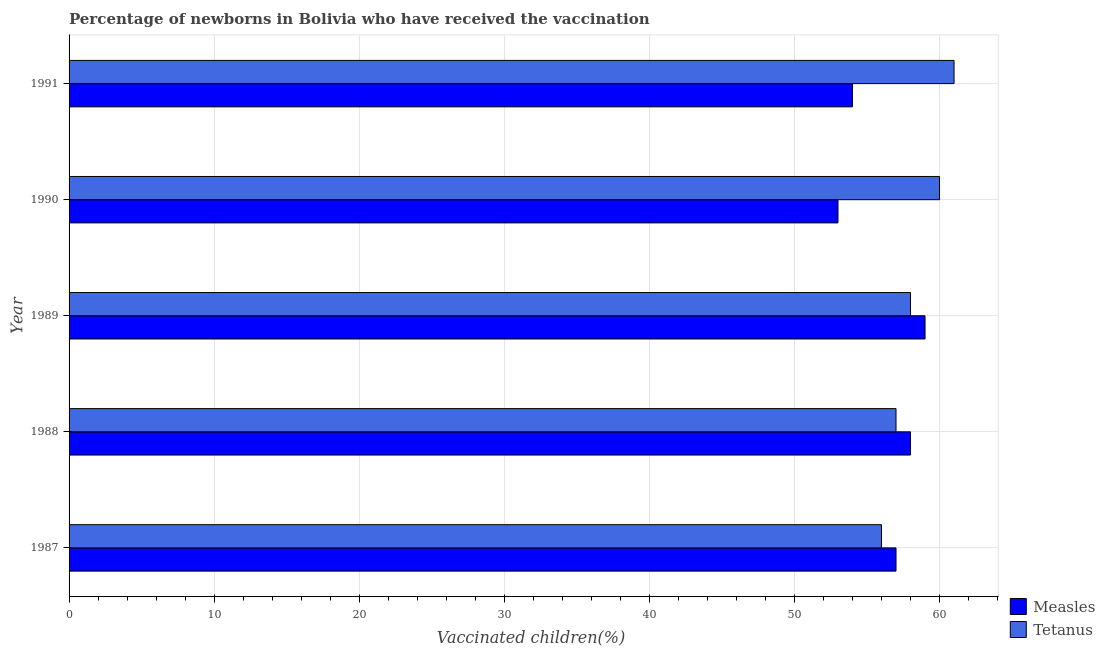How many groups of bars are there?
Ensure brevity in your answer.  5. Are the number of bars on each tick of the Y-axis equal?
Your answer should be compact. Yes. How many bars are there on the 3rd tick from the top?
Your answer should be very brief. 2. How many bars are there on the 1st tick from the bottom?
Your response must be concise. 2. What is the percentage of newborns who received vaccination for tetanus in 1991?
Offer a very short reply. 61. Across all years, what is the maximum percentage of newborns who received vaccination for measles?
Give a very brief answer. 59. Across all years, what is the minimum percentage of newborns who received vaccination for tetanus?
Your answer should be very brief. 56. In which year was the percentage of newborns who received vaccination for measles maximum?
Keep it short and to the point. 1989. In which year was the percentage of newborns who received vaccination for tetanus minimum?
Make the answer very short. 1987. What is the total percentage of newborns who received vaccination for tetanus in the graph?
Provide a short and direct response. 292. What is the difference between the percentage of newborns who received vaccination for tetanus in 1988 and that in 1991?
Make the answer very short. -4. What is the difference between the percentage of newborns who received vaccination for measles in 1991 and the percentage of newborns who received vaccination for tetanus in 1987?
Offer a very short reply. -2. What is the average percentage of newborns who received vaccination for tetanus per year?
Keep it short and to the point. 58.4. In the year 1988, what is the difference between the percentage of newborns who received vaccination for measles and percentage of newborns who received vaccination for tetanus?
Give a very brief answer. 1. What is the ratio of the percentage of newborns who received vaccination for measles in 1988 to that in 1991?
Your answer should be compact. 1.07. Is the percentage of newborns who received vaccination for measles in 1990 less than that in 1991?
Make the answer very short. Yes. Is the difference between the percentage of newborns who received vaccination for measles in 1989 and 1990 greater than the difference between the percentage of newborns who received vaccination for tetanus in 1989 and 1990?
Your response must be concise. Yes. What is the difference between the highest and the second highest percentage of newborns who received vaccination for tetanus?
Provide a succinct answer. 1. Is the sum of the percentage of newborns who received vaccination for tetanus in 1987 and 1991 greater than the maximum percentage of newborns who received vaccination for measles across all years?
Offer a very short reply. Yes. What does the 1st bar from the top in 1987 represents?
Make the answer very short. Tetanus. What does the 2nd bar from the bottom in 1987 represents?
Provide a succinct answer. Tetanus. Are all the bars in the graph horizontal?
Provide a short and direct response. Yes. How many years are there in the graph?
Provide a succinct answer. 5. Does the graph contain any zero values?
Provide a short and direct response. No. How many legend labels are there?
Offer a terse response. 2. How are the legend labels stacked?
Your answer should be compact. Vertical. What is the title of the graph?
Your answer should be compact. Percentage of newborns in Bolivia who have received the vaccination. What is the label or title of the X-axis?
Your answer should be very brief. Vaccinated children(%)
. What is the Vaccinated children(%)
 of Tetanus in 1987?
Keep it short and to the point. 56. What is the Vaccinated children(%)
 in Measles in 1988?
Provide a succinct answer. 58. What is the Vaccinated children(%)
 in Measles in 1989?
Your answer should be compact. 59. What is the Vaccinated children(%)
 of Tetanus in 1989?
Give a very brief answer. 58. What is the Vaccinated children(%)
 in Measles in 1990?
Your answer should be compact. 53. What is the Vaccinated children(%)
 in Measles in 1991?
Your answer should be very brief. 54. Across all years, what is the maximum Vaccinated children(%)
 in Measles?
Provide a succinct answer. 59. Across all years, what is the minimum Vaccinated children(%)
 of Measles?
Give a very brief answer. 53. What is the total Vaccinated children(%)
 in Measles in the graph?
Your answer should be compact. 281. What is the total Vaccinated children(%)
 in Tetanus in the graph?
Make the answer very short. 292. What is the difference between the Vaccinated children(%)
 in Tetanus in 1987 and that in 1989?
Offer a terse response. -2. What is the difference between the Vaccinated children(%)
 in Measles in 1987 and that in 1990?
Keep it short and to the point. 4. What is the difference between the Vaccinated children(%)
 in Measles in 1987 and that in 1991?
Give a very brief answer. 3. What is the difference between the Vaccinated children(%)
 of Tetanus in 1987 and that in 1991?
Provide a short and direct response. -5. What is the difference between the Vaccinated children(%)
 of Measles in 1988 and that in 1989?
Your answer should be compact. -1. What is the difference between the Vaccinated children(%)
 in Tetanus in 1988 and that in 1989?
Your response must be concise. -1. What is the difference between the Vaccinated children(%)
 in Tetanus in 1988 and that in 1990?
Your answer should be compact. -3. What is the difference between the Vaccinated children(%)
 in Measles in 1990 and that in 1991?
Provide a succinct answer. -1. What is the difference between the Vaccinated children(%)
 of Tetanus in 1990 and that in 1991?
Make the answer very short. -1. What is the difference between the Vaccinated children(%)
 in Measles in 1988 and the Vaccinated children(%)
 in Tetanus in 1990?
Provide a succinct answer. -2. What is the difference between the Vaccinated children(%)
 in Measles in 1989 and the Vaccinated children(%)
 in Tetanus in 1990?
Provide a short and direct response. -1. What is the difference between the Vaccinated children(%)
 in Measles in 1989 and the Vaccinated children(%)
 in Tetanus in 1991?
Your response must be concise. -2. What is the average Vaccinated children(%)
 in Measles per year?
Ensure brevity in your answer.  56.2. What is the average Vaccinated children(%)
 of Tetanus per year?
Provide a short and direct response. 58.4. In the year 1987, what is the difference between the Vaccinated children(%)
 of Measles and Vaccinated children(%)
 of Tetanus?
Ensure brevity in your answer.  1. In the year 1989, what is the difference between the Vaccinated children(%)
 of Measles and Vaccinated children(%)
 of Tetanus?
Your answer should be very brief. 1. In the year 1990, what is the difference between the Vaccinated children(%)
 of Measles and Vaccinated children(%)
 of Tetanus?
Offer a terse response. -7. What is the ratio of the Vaccinated children(%)
 in Measles in 1987 to that in 1988?
Offer a very short reply. 0.98. What is the ratio of the Vaccinated children(%)
 of Tetanus in 1987 to that in 1988?
Offer a terse response. 0.98. What is the ratio of the Vaccinated children(%)
 of Measles in 1987 to that in 1989?
Give a very brief answer. 0.97. What is the ratio of the Vaccinated children(%)
 in Tetanus in 1987 to that in 1989?
Make the answer very short. 0.97. What is the ratio of the Vaccinated children(%)
 in Measles in 1987 to that in 1990?
Your answer should be compact. 1.08. What is the ratio of the Vaccinated children(%)
 in Tetanus in 1987 to that in 1990?
Make the answer very short. 0.93. What is the ratio of the Vaccinated children(%)
 of Measles in 1987 to that in 1991?
Offer a terse response. 1.06. What is the ratio of the Vaccinated children(%)
 of Tetanus in 1987 to that in 1991?
Your response must be concise. 0.92. What is the ratio of the Vaccinated children(%)
 of Measles in 1988 to that in 1989?
Keep it short and to the point. 0.98. What is the ratio of the Vaccinated children(%)
 in Tetanus in 1988 to that in 1989?
Provide a short and direct response. 0.98. What is the ratio of the Vaccinated children(%)
 in Measles in 1988 to that in 1990?
Keep it short and to the point. 1.09. What is the ratio of the Vaccinated children(%)
 of Measles in 1988 to that in 1991?
Make the answer very short. 1.07. What is the ratio of the Vaccinated children(%)
 of Tetanus in 1988 to that in 1991?
Give a very brief answer. 0.93. What is the ratio of the Vaccinated children(%)
 of Measles in 1989 to that in 1990?
Provide a succinct answer. 1.11. What is the ratio of the Vaccinated children(%)
 in Tetanus in 1989 to that in 1990?
Offer a very short reply. 0.97. What is the ratio of the Vaccinated children(%)
 of Measles in 1989 to that in 1991?
Make the answer very short. 1.09. What is the ratio of the Vaccinated children(%)
 in Tetanus in 1989 to that in 1991?
Your answer should be compact. 0.95. What is the ratio of the Vaccinated children(%)
 in Measles in 1990 to that in 1991?
Your response must be concise. 0.98. What is the ratio of the Vaccinated children(%)
 of Tetanus in 1990 to that in 1991?
Make the answer very short. 0.98. What is the difference between the highest and the lowest Vaccinated children(%)
 in Measles?
Provide a succinct answer. 6. 